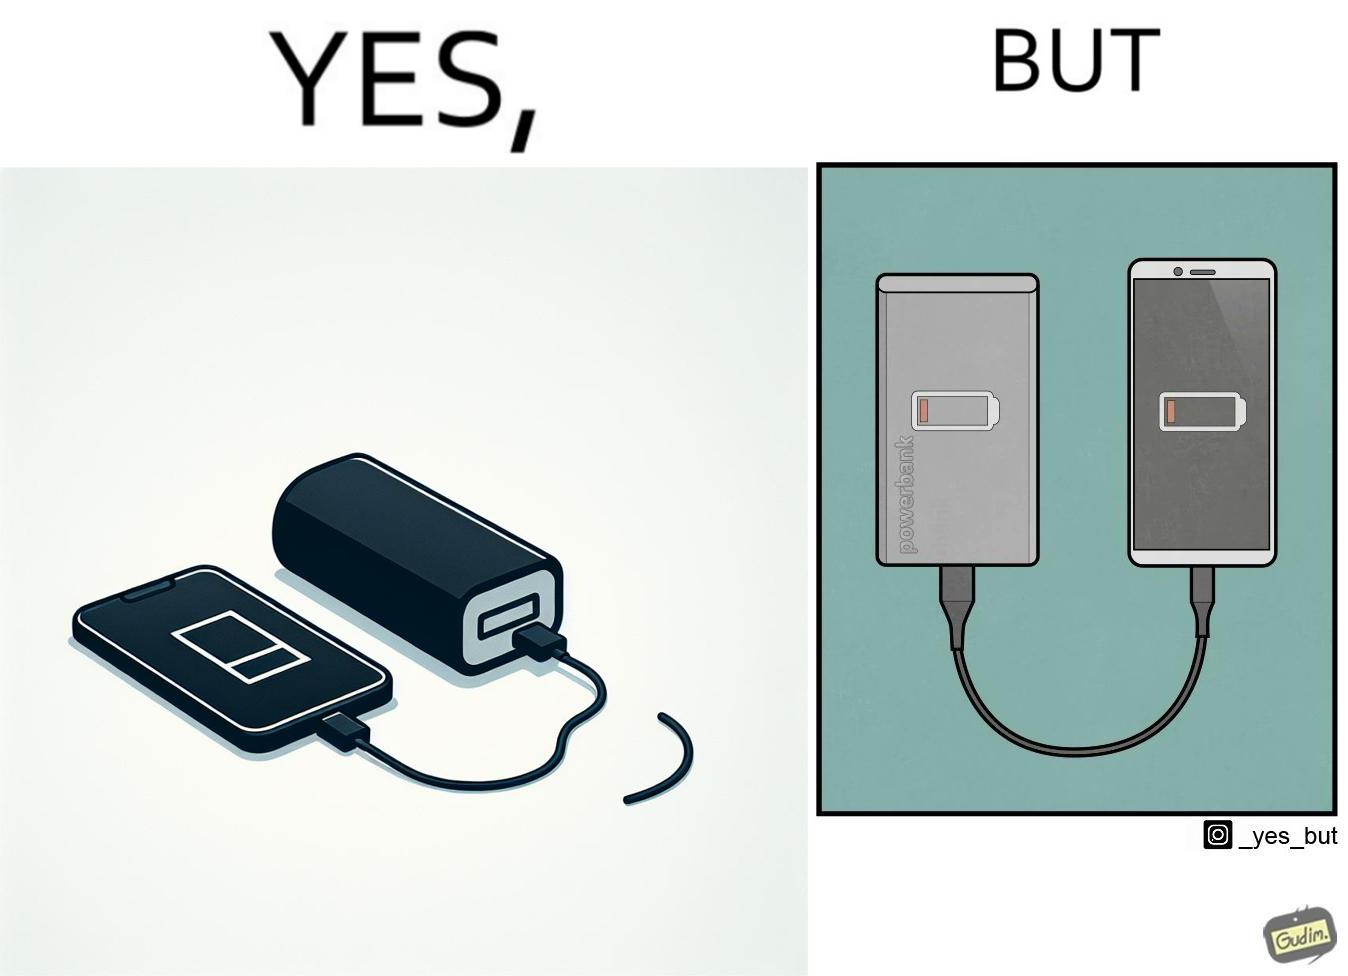Is this a satirical image? Yes, this image is satirical. 